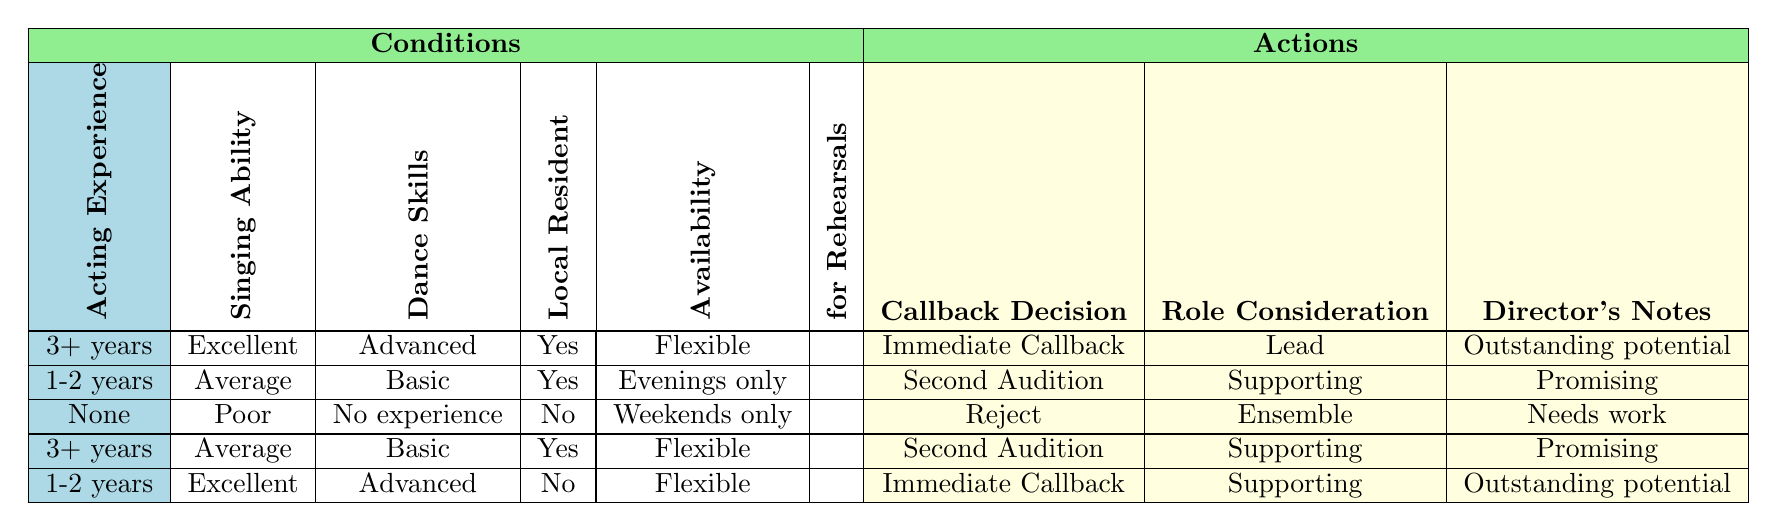What role is given to someone with 3+ years of acting experience, excellent singing ability, advanced dance skills, is a local resident, and has flexible rehearsal availability? Looking at the table, the row matching these conditions (3+ years, Excellent, Advanced, Yes, Flexible) shows that the actions recommended are "Immediate Callback," "Lead," and "Outstanding potential." Thus, the role consideration for this individual would be "Lead."
Answer: Lead What is the callback decision for a person with no acting experience, poor singing ability, no dance experience, who is not a local resident, and is only available on weekends? The table entry for these specific conditions (None, Poor, No experience, No, Weekends only) indicates that the callback decision is "Reject."
Answer: Reject Are individuals with 1-2 years of experience and excellent singing ability considered for lead roles? From the table, individuals with 1-2 years of acting experience and excellent singing ability (1-2 years, Excellent, Advanced, No, Flexible), have "Immediate Callback" and "Supporting" role consideration. Hence, they are not awarded a lead role in this scenario.
Answer: No How many individuals in the table are local residents? The table indicates three entries where the condition "Local Resident" is "Yes." By counting these entries, we find there are three individuals noted as local residents in the table.
Answer: 3 What are the actions for someone with 3+ years of experience, average singing ability, basic dance skills, is a local resident, and has flexible availability? Referring to the table, the conditions (3+ years, Average, Basic, Yes, Flexible) correspond to the actions "Second Audition," "Supporting," and "Promising." Thus, these are the actions decided for such an individual.
Answer: Second Audition, Supporting, Promising What is the director's note for someone with 1-2 years of acting experience, average singing ability, basic dance skills, is a local resident, and available only in the evenings? According to the table, for these conditions (1-2 years, Average, Basic, Yes, Evenings only), the director's note given is "Promising."
Answer: Promising Is it true that any applicant with 3+ years of acting experience receives an immediate callback? Examining the table, there are two rows for applicants with 3+ years of experience, but one results in "Second Audition." Therefore, it is false that all such applicants receive an immediate callback.
Answer: No How many callback decisions lead to an immediate callback in the table? Analyzing the table, only one entry (3+ years, Excellent, Advanced, Yes, Flexible) corresponds to an "Immediate Callback." Thus, there is only one immediate callback decision noted in this context.
Answer: 1 